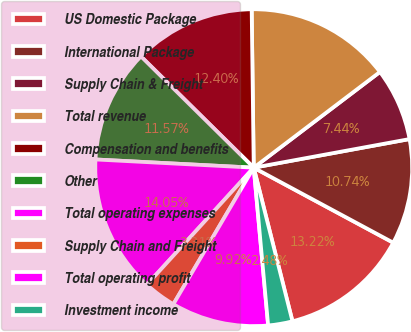Convert chart to OTSL. <chart><loc_0><loc_0><loc_500><loc_500><pie_chart><fcel>US Domestic Package<fcel>International Package<fcel>Supply Chain & Freight<fcel>Total revenue<fcel>Compensation and benefits<fcel>Other<fcel>Total operating expenses<fcel>Supply Chain and Freight<fcel>Total operating profit<fcel>Investment income<nl><fcel>13.22%<fcel>10.74%<fcel>7.44%<fcel>14.88%<fcel>12.4%<fcel>11.57%<fcel>14.05%<fcel>3.31%<fcel>9.92%<fcel>2.48%<nl></chart> 